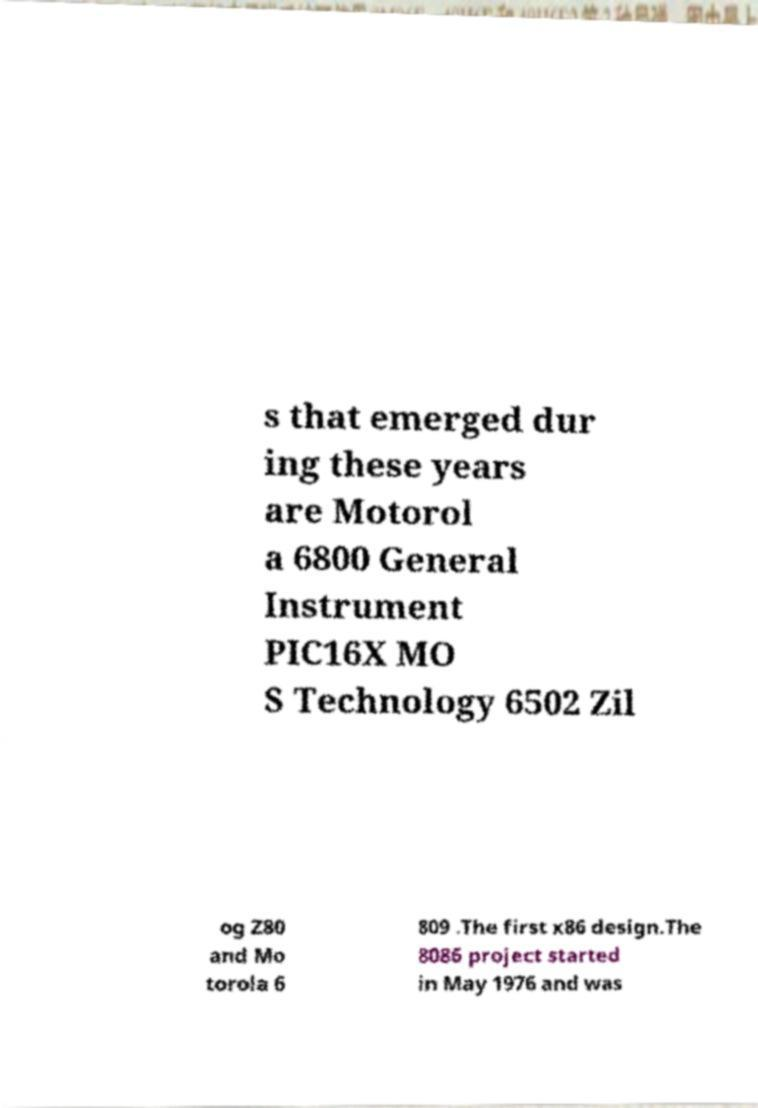For documentation purposes, I need the text within this image transcribed. Could you provide that? s that emerged dur ing these years are Motorol a 6800 General Instrument PIC16X MO S Technology 6502 Zil og Z80 and Mo torola 6 809 .The first x86 design.The 8086 project started in May 1976 and was 